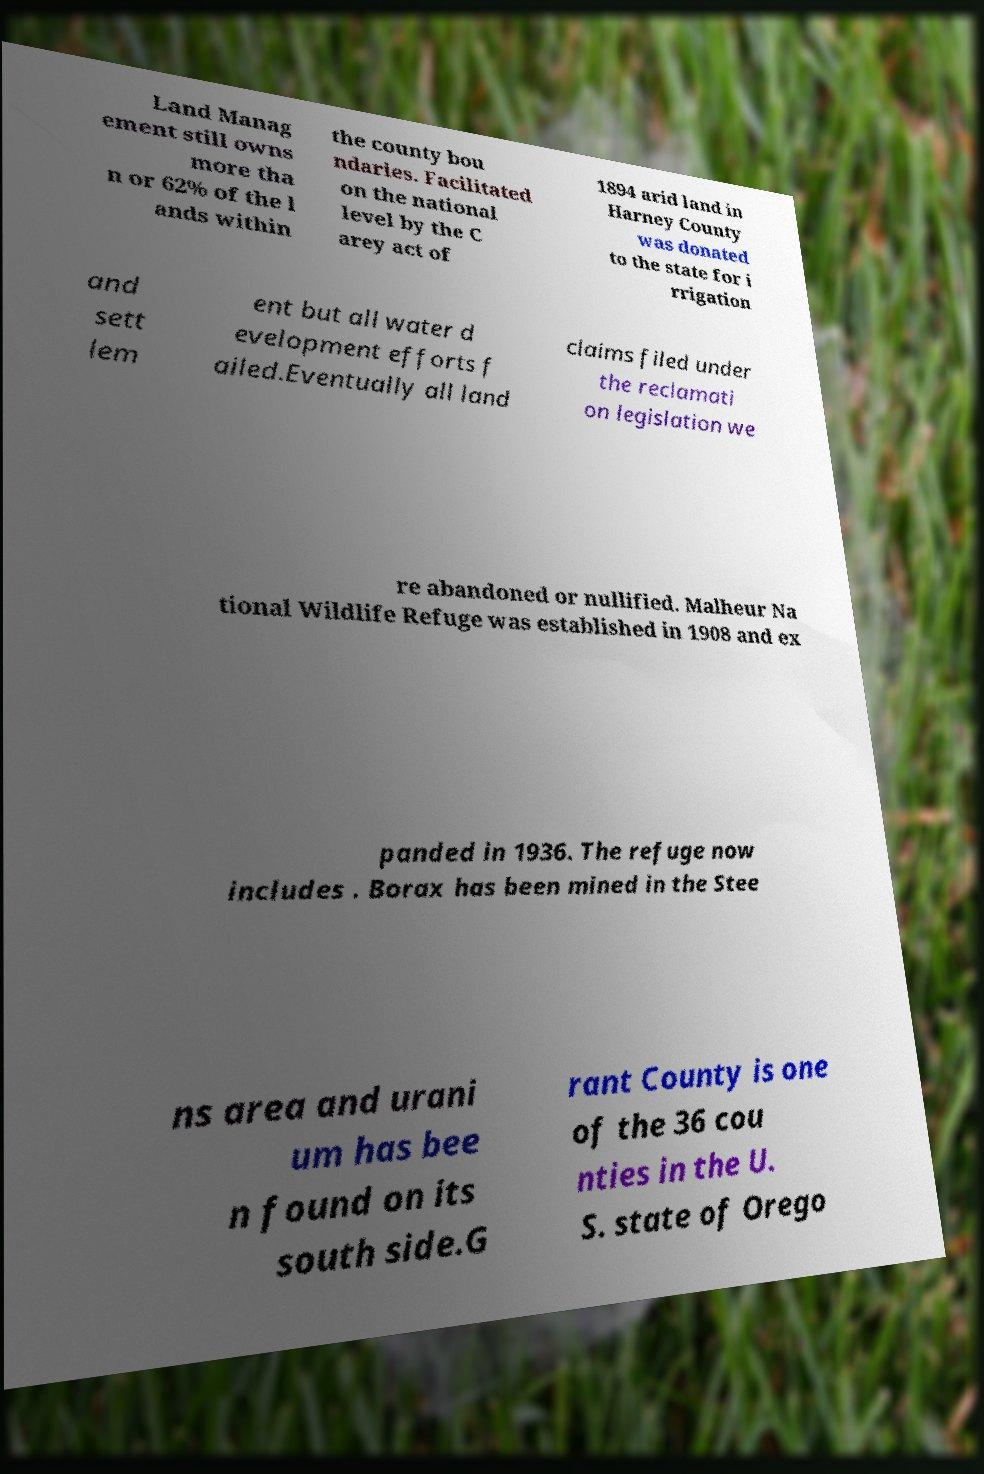For documentation purposes, I need the text within this image transcribed. Could you provide that? Land Manag ement still owns more tha n or 62% of the l ands within the county bou ndaries. Facilitated on the national level by the C arey act of 1894 arid land in Harney County was donated to the state for i rrigation and sett lem ent but all water d evelopment efforts f ailed.Eventually all land claims filed under the reclamati on legislation we re abandoned or nullified. Malheur Na tional Wildlife Refuge was established in 1908 and ex panded in 1936. The refuge now includes . Borax has been mined in the Stee ns area and urani um has bee n found on its south side.G rant County is one of the 36 cou nties in the U. S. state of Orego 